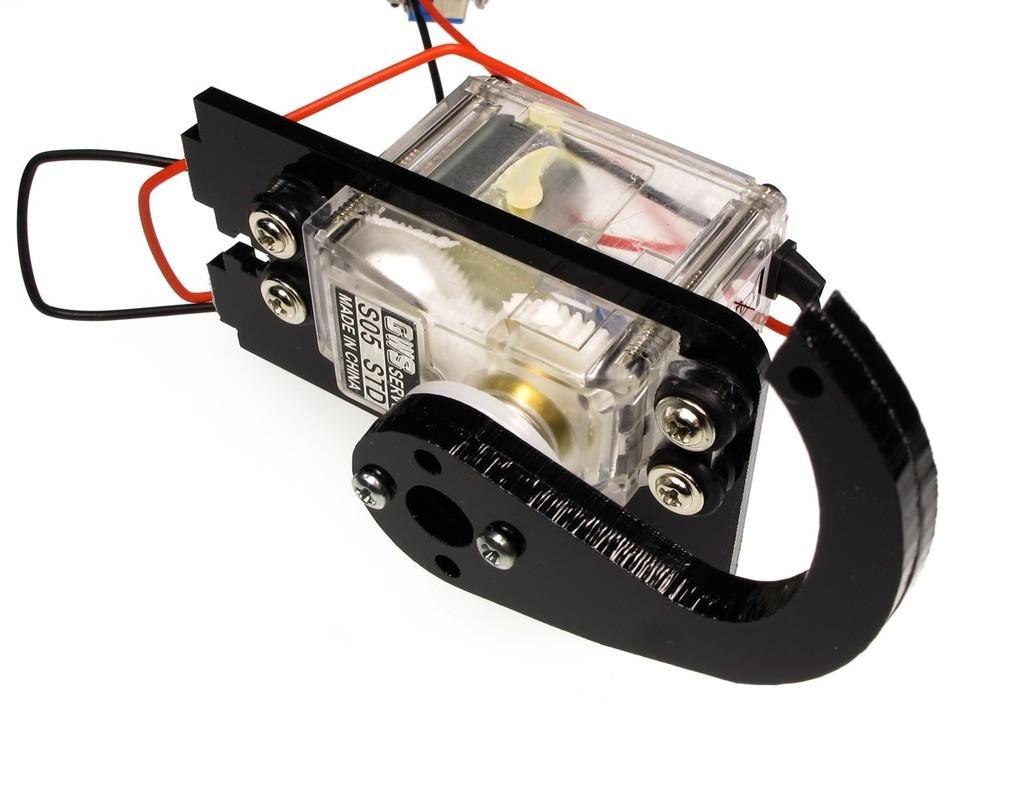How would you summarize this image in a sentence or two? In this image we can see one object with wires looks like a machine and there is a white background. 